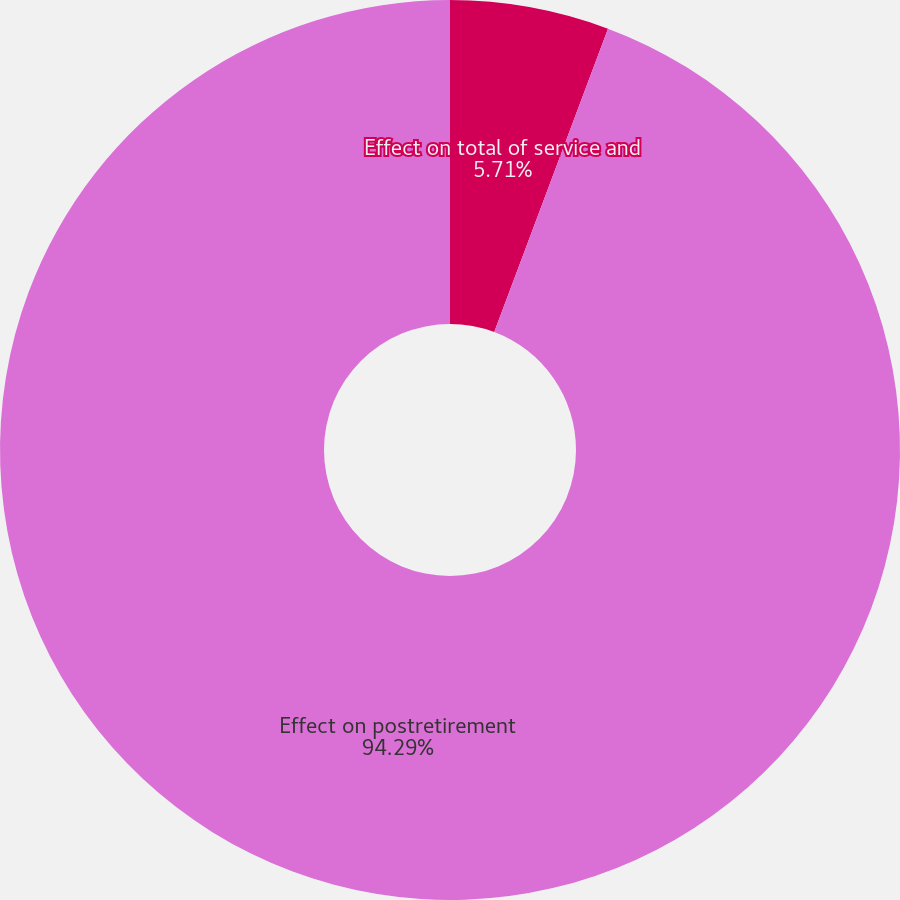<chart> <loc_0><loc_0><loc_500><loc_500><pie_chart><fcel>Effect on total of service and<fcel>Effect on postretirement<nl><fcel>5.71%<fcel>94.29%<nl></chart> 